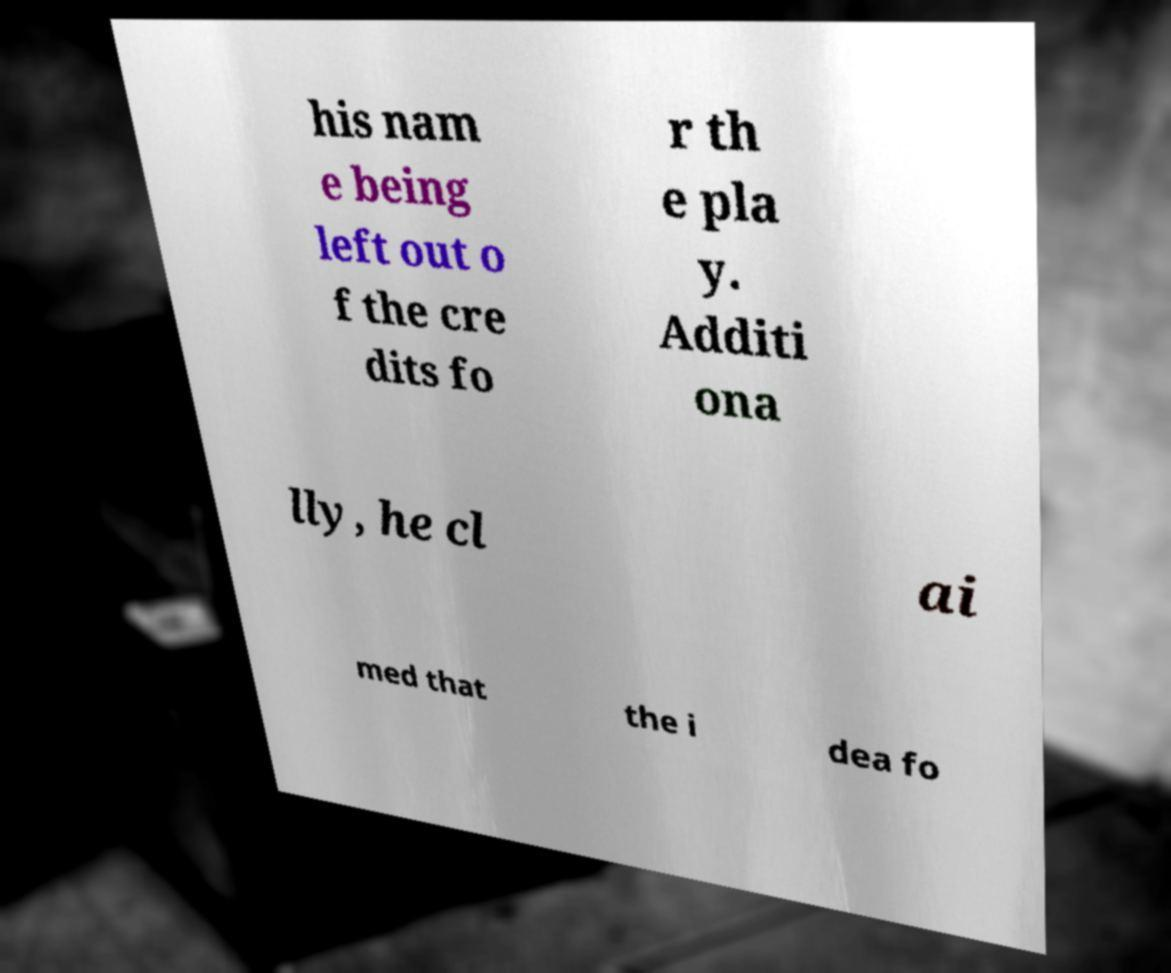I need the written content from this picture converted into text. Can you do that? his nam e being left out o f the cre dits fo r th e pla y. Additi ona lly, he cl ai med that the i dea fo 